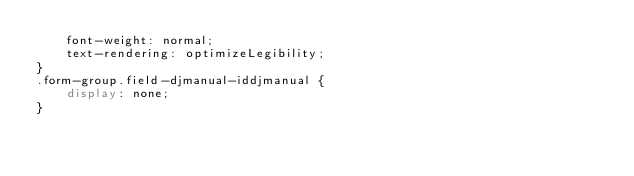<code> <loc_0><loc_0><loc_500><loc_500><_CSS_>    font-weight: normal;
    text-rendering: optimizeLegibility;
}
.form-group.field-djmanual-iddjmanual {
    display: none;
}
</code> 